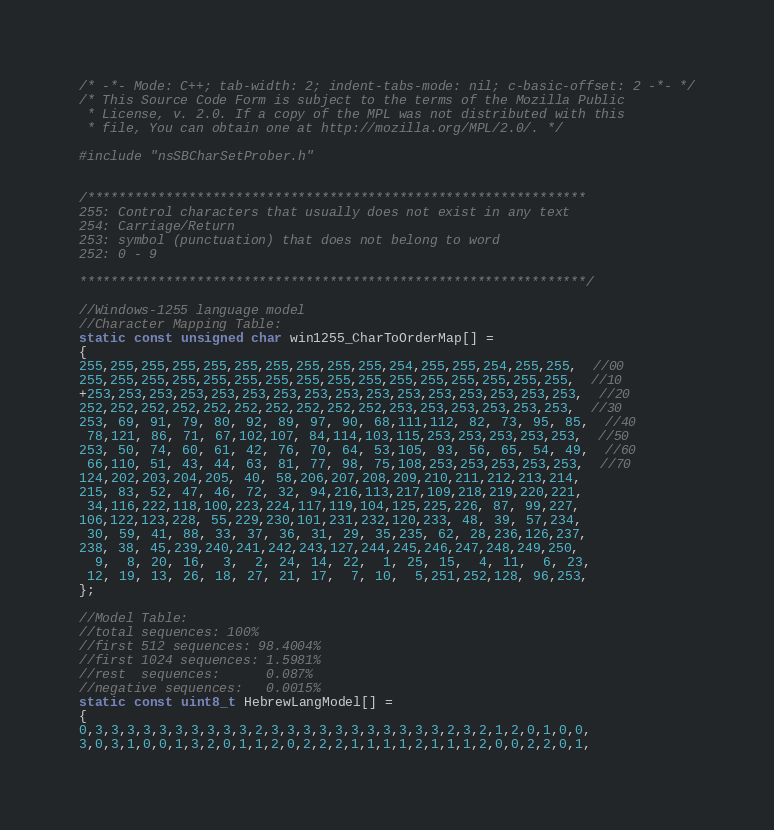<code> <loc_0><loc_0><loc_500><loc_500><_C++_>/* -*- Mode: C++; tab-width: 2; indent-tabs-mode: nil; c-basic-offset: 2 -*- */
/* This Source Code Form is subject to the terms of the Mozilla Public
 * License, v. 2.0. If a copy of the MPL was not distributed with this
 * file, You can obtain one at http://mozilla.org/MPL/2.0/. */

#include "nsSBCharSetProber.h"


/****************************************************************
255: Control characters that usually does not exist in any text
254: Carriage/Return
253: symbol (punctuation) that does not belong to word
252: 0 - 9

*****************************************************************/

//Windows-1255 language model
//Character Mapping Table:
static const unsigned char win1255_CharToOrderMap[] =
{
255,255,255,255,255,255,255,255,255,255,254,255,255,254,255,255,  //00
255,255,255,255,255,255,255,255,255,255,255,255,255,255,255,255,  //10
+253,253,253,253,253,253,253,253,253,253,253,253,253,253,253,253,  //20
252,252,252,252,252,252,252,252,252,252,253,253,253,253,253,253,  //30
253, 69, 91, 79, 80, 92, 89, 97, 90, 68,111,112, 82, 73, 95, 85,  //40
 78,121, 86, 71, 67,102,107, 84,114,103,115,253,253,253,253,253,  //50
253, 50, 74, 60, 61, 42, 76, 70, 64, 53,105, 93, 56, 65, 54, 49,  //60
 66,110, 51, 43, 44, 63, 81, 77, 98, 75,108,253,253,253,253,253,  //70
124,202,203,204,205, 40, 58,206,207,208,209,210,211,212,213,214,
215, 83, 52, 47, 46, 72, 32, 94,216,113,217,109,218,219,220,221,
 34,116,222,118,100,223,224,117,119,104,125,225,226, 87, 99,227,
106,122,123,228, 55,229,230,101,231,232,120,233, 48, 39, 57,234,
 30, 59, 41, 88, 33, 37, 36, 31, 29, 35,235, 62, 28,236,126,237,
238, 38, 45,239,240,241,242,243,127,244,245,246,247,248,249,250,
  9,  8, 20, 16,  3,  2, 24, 14, 22,  1, 25, 15,  4, 11,  6, 23,
 12, 19, 13, 26, 18, 27, 21, 17,  7, 10,  5,251,252,128, 96,253,
};

//Model Table: 
//total sequences: 100%
//first 512 sequences: 98.4004%
//first 1024 sequences: 1.5981%
//rest  sequences:      0.087%
//negative sequences:   0.0015% 
static const uint8_t HebrewLangModel[] = 
{
0,3,3,3,3,3,3,3,3,3,3,2,3,3,3,3,3,3,3,3,3,3,3,2,3,2,1,2,0,1,0,0,
3,0,3,1,0,0,1,3,2,0,1,1,2,0,2,2,2,1,1,1,1,2,1,1,1,2,0,0,2,2,0,1,</code> 